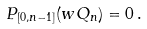<formula> <loc_0><loc_0><loc_500><loc_500>{ P } _ { [ 0 , n - 1 ] } ( w Q _ { n } ) = 0 \, .</formula> 